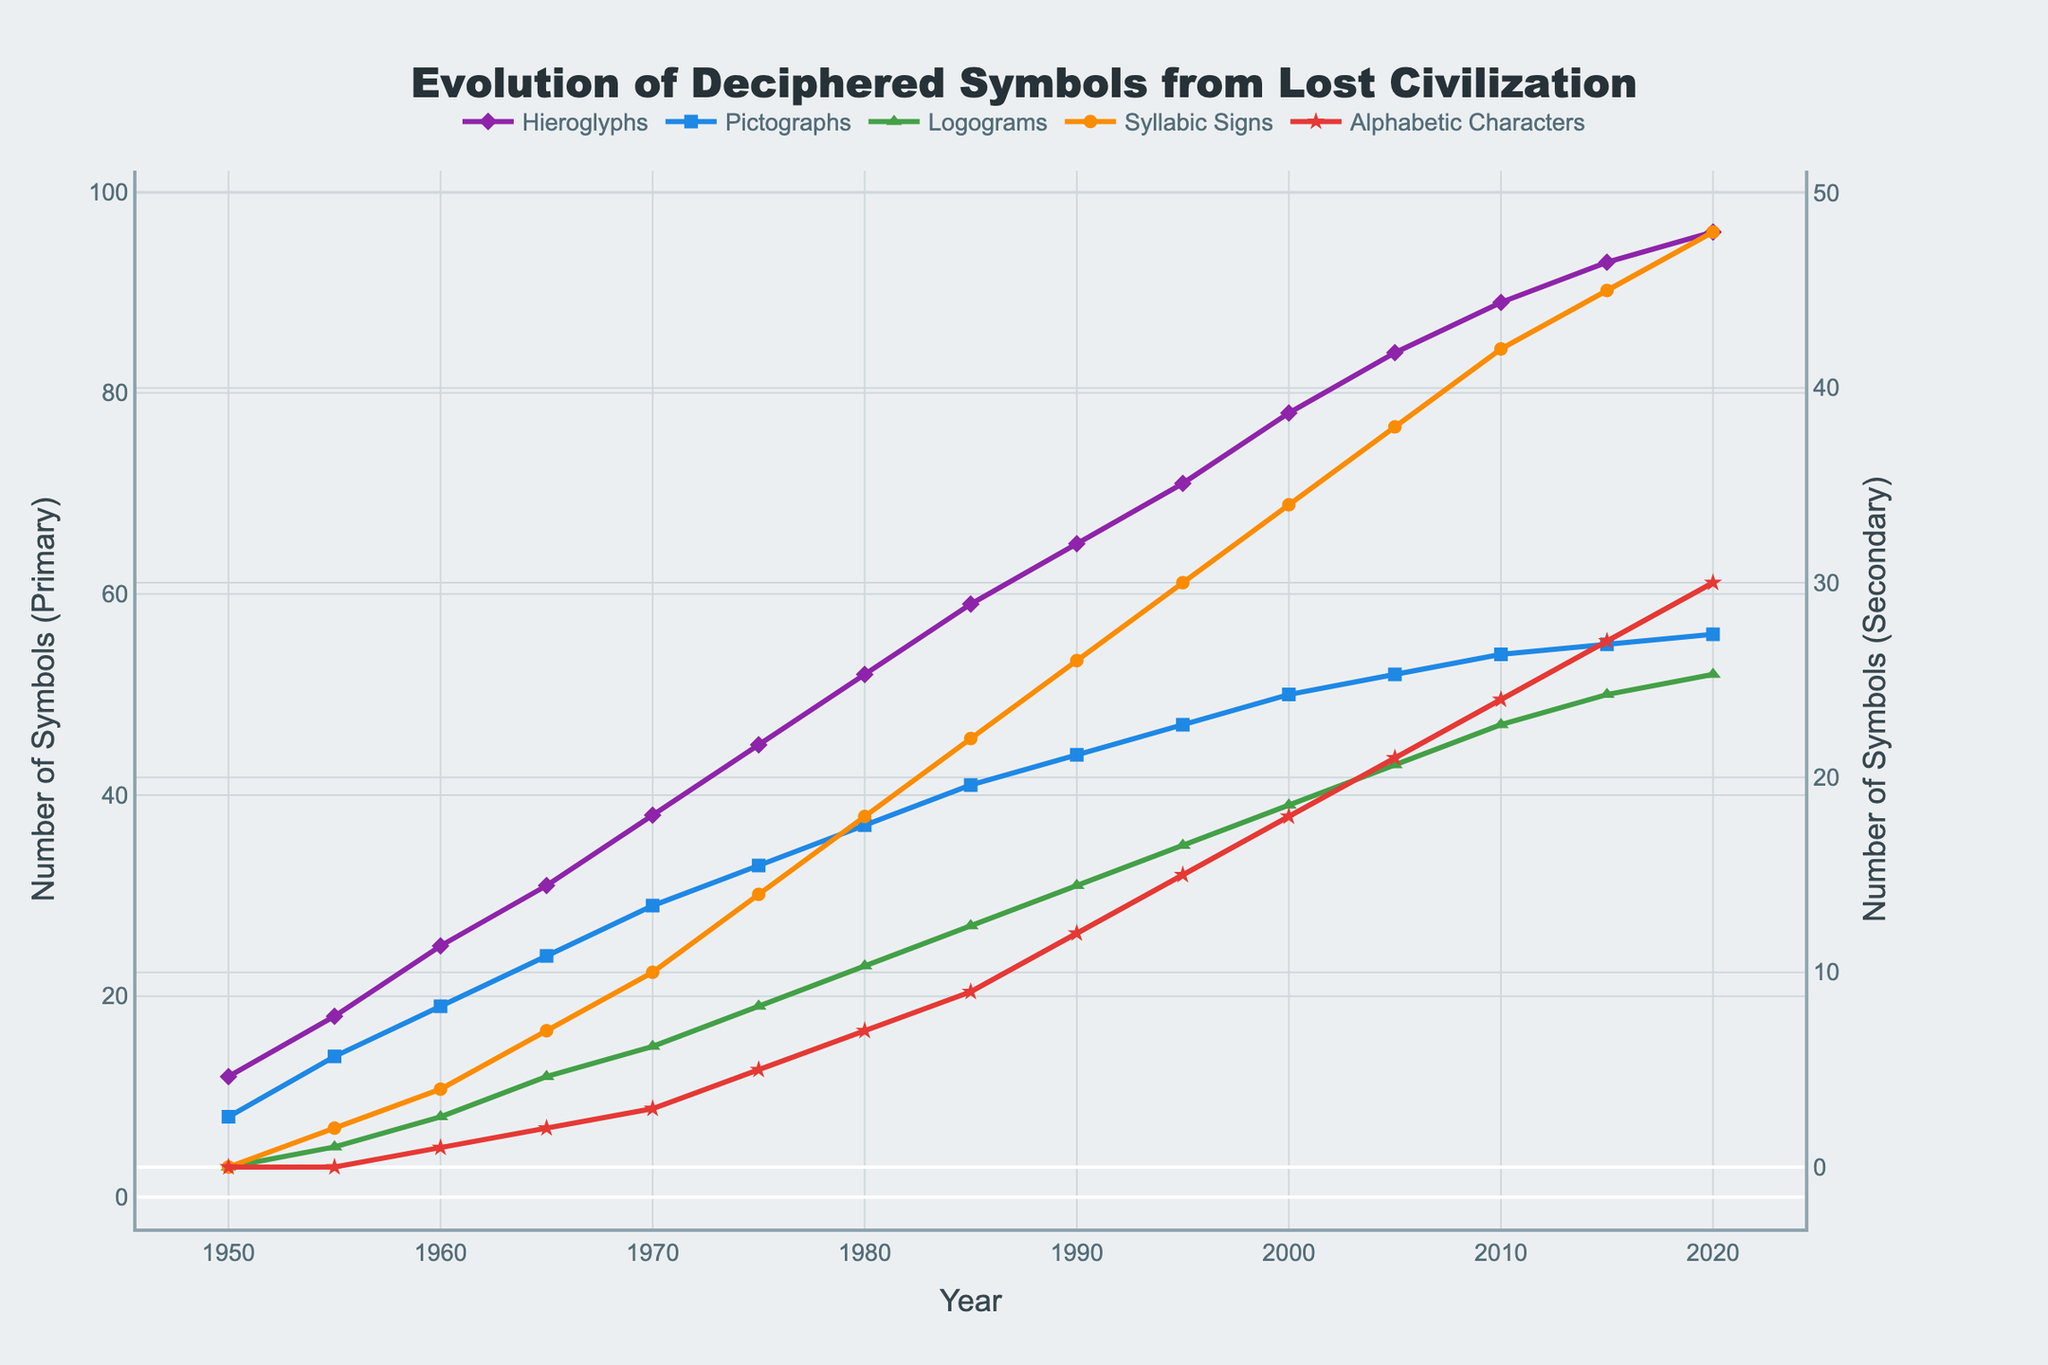What's the total number of symbols deciphered in the year 1980? To find the total number of symbols deciphered in 1980, we sum the numbers of all types of symbols deciphered in that year. That is: 52 (Hieroglyphs) + 37 (Pictographs) + 23 (Logograms) + 18 (Syllabic Signs) + 7 (Alphabetic Characters) = 137
Answer: 137 Which type of symbol had the greatest increase between 1950 and 2020? To determine which type of symbol had the greatest increase, we subtract the number of symbols in 1950 from the number in 2020 for each type. The increases are: 
Hieroglyphs: 96 - 12 = 84,
Pictographs: 56 - 8 = 48,
Logograms: 52 - 3 = 49,
Syllabic Signs: 48 - 0 = 48,
Alphabetic Characters: 30 - 0 = 30.
The greatest increase is 84 for Hieroglyphs
Answer: Hieroglyphs How many more Logograms were deciphered than Alphabetic Characters in 2015? To find how many more Logograms were deciphered than Alphabetic Characters in 2015, we subtract the number of deciphered Alphabetic Characters from the number of deciphered Logograms. That is: 50 (Logograms) - 27 (Alphabetic Characters) = 23
Answer: 23 What is the average number of Hieroglyphs deciphered per decade from 1960 to 2000? To find the average number of Hieroglyphs deciphered per decade from 1960 to 2000, we first sum the number of deciphered Hieroglyphs at the start and end of each decade, then divide by the number of decades. Calculations:
1960: 25, 1970: 38, 1980: 52, 1990: 65, 2000: 78. Total = 25 + 38 + 52 + 65 + 78 = 258. Number of decades = 4 (1960-1969, 1970-1979, 1980-1989, 1990-1999). Average = 258 / 4 = 64.5
Answer: 64.5 In which year did Syllabic Signs first surpass 20 in number? To find the year when Syllabic Signs first surpassed 20, we need to look at the values over the years until we find the first instance where the number is greater than 20. The first occurrence is in 1985 where there are 22 Syllabic Signs.
Answer: 1985 Between which consecutive years did Alphabetic Characters see the highest growth? To find the highest growth of Alphabetic Characters between consecutive years, subtract the number of symbols in each year from the previous year and find the maximum difference. Calculations: 
1955-1950: 0-0=0,
1960-1955: 1-0=1,
1965-1960: 2-1=1,
1970-1965: 3-2=1,
1975-1970: 5-3=2,
1980-1975: 7-5=2,
1985-1980: 9-7=2,
1990-1985: 12-9=3,
1995-1990: 15-12=3,
2000-1995: 18-15=3,
2005-2000: 21-18=3,
2010-2005: 24-21=3,
2015-2010: 27-24=3,
2020-2015: 30-27=3. 
The highest growth of 3 happened multiple times: between 1990-1995, 1995-2000, 2000-2005, 2005-2010, 2010-2015, and 2015-2020.
Answer: 1990-1995, 1995-2000, 2000-2005, 2005-2010, 2010-2015, 2015-2020 What is the difference in the number of deciphered Pictographs and Syllabic Signs in the year 1990? To find the difference in the number of deciphered Pictographs and Syllabic Signs in 1990, we subtract the number of Syllabic Signs from the number of Pictographs. That is: 44 (Pictographs) - 26 (Syllabic Signs) = 18
Answer: 18 